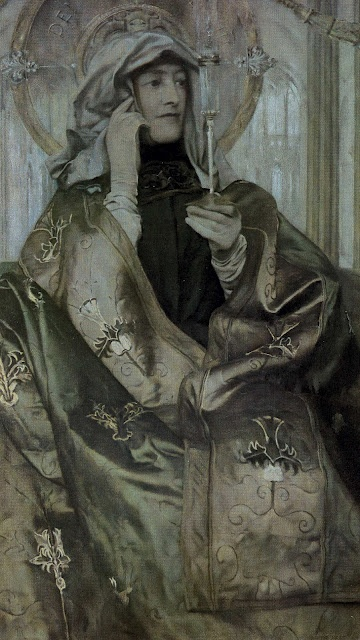If this scene were part of a story, what might be happening right before and right after this moment? Before this moment, the woman might have been in a grand hall, receiving visitors or engaging in a solemn ceremony that required her blessing. The white flower she holds could have been presented to her as a symbol of peace or a token of gratitude. Right after this moment, she might proceed to a private garden, where she reflects on her thoughts and contemplates the day's events. She could be preparing to conduct a mystical ritual or write in a journal, documenting her experiences and the insights gained from her contemplations. 